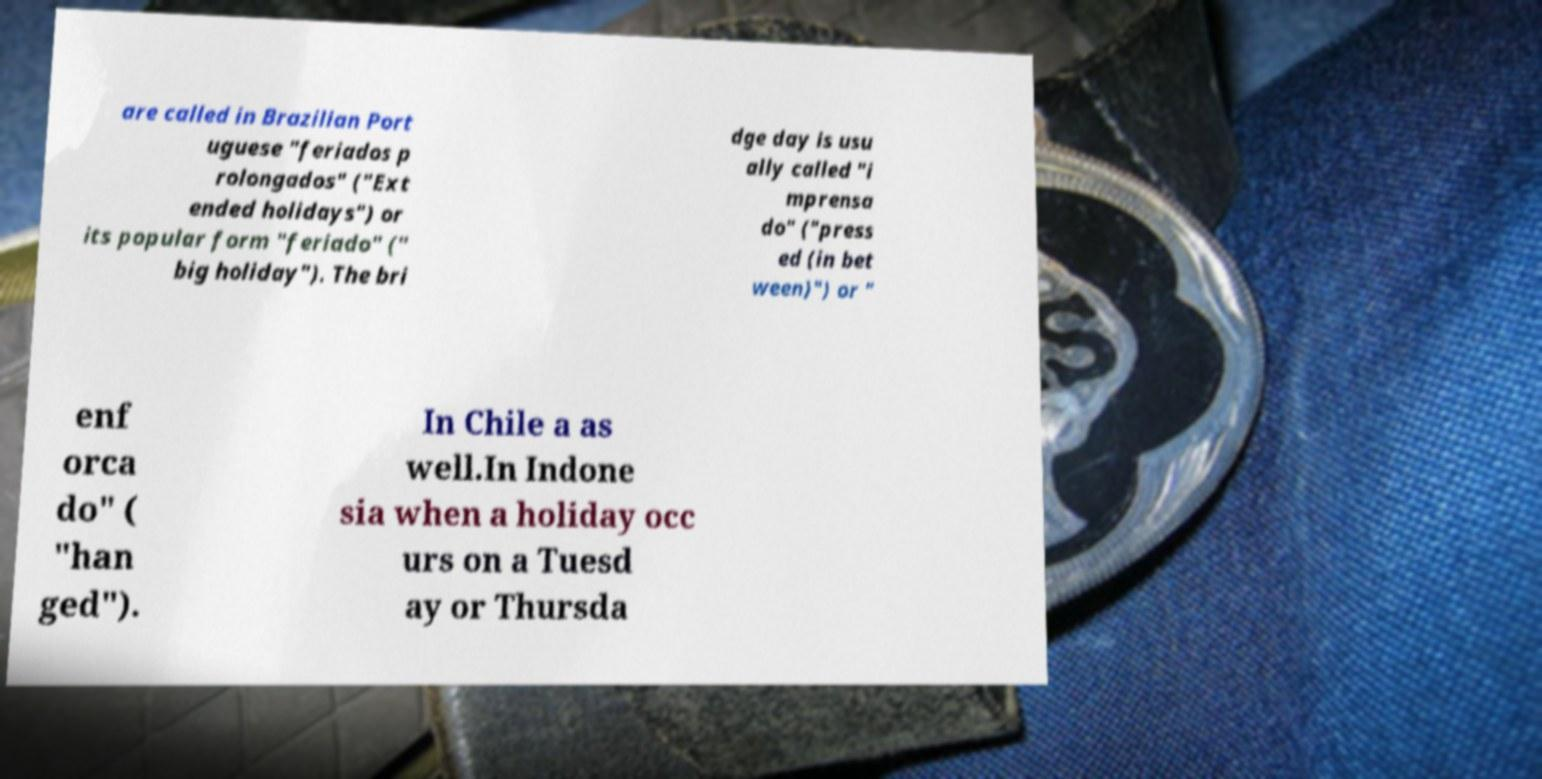Please identify and transcribe the text found in this image. are called in Brazilian Port uguese "feriados p rolongados" ("Ext ended holidays") or its popular form "feriado" (" big holiday"). The bri dge day is usu ally called "i mprensa do" ("press ed (in bet ween)") or " enf orca do" ( "han ged"). In Chile a as well.In Indone sia when a holiday occ urs on a Tuesd ay or Thursda 